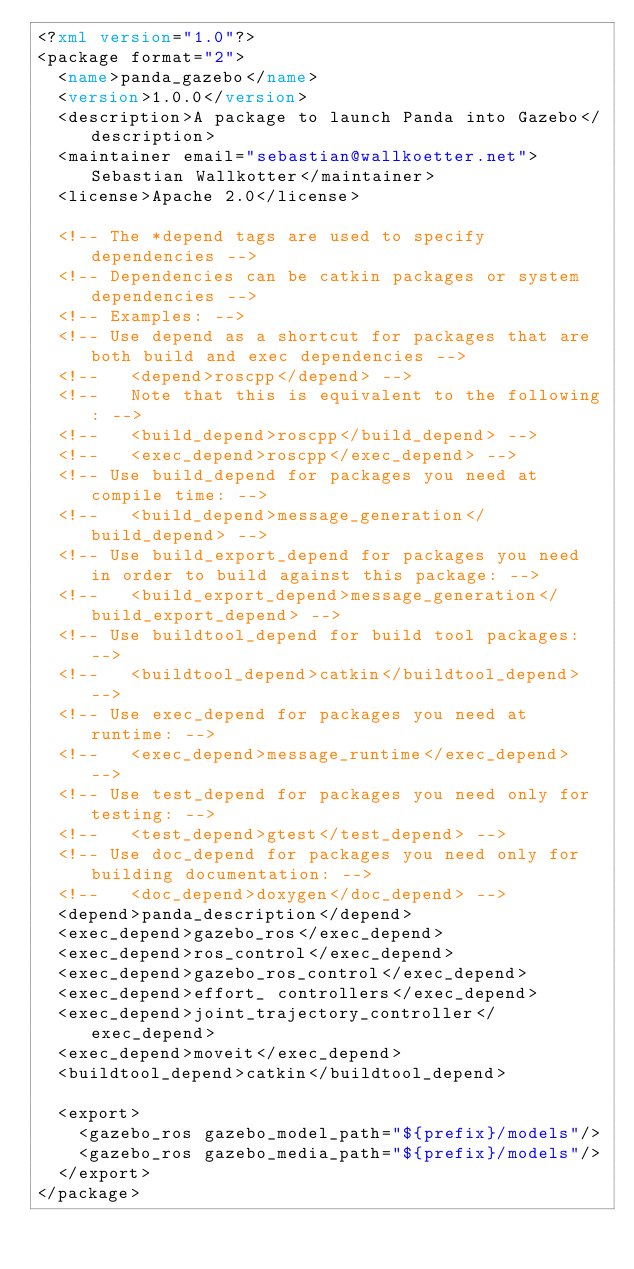Convert code to text. <code><loc_0><loc_0><loc_500><loc_500><_XML_><?xml version="1.0"?>
<package format="2">
  <name>panda_gazebo</name>
  <version>1.0.0</version>
  <description>A package to launch Panda into Gazebo</description>
  <maintainer email="sebastian@wallkoetter.net">Sebastian Wallkotter</maintainer>
  <license>Apache 2.0</license>

  <!-- The *depend tags are used to specify dependencies -->
  <!-- Dependencies can be catkin packages or system dependencies -->
  <!-- Examples: -->
  <!-- Use depend as a shortcut for packages that are both build and exec dependencies -->
  <!--   <depend>roscpp</depend> -->
  <!--   Note that this is equivalent to the following: -->
  <!--   <build_depend>roscpp</build_depend> -->
  <!--   <exec_depend>roscpp</exec_depend> -->
  <!-- Use build_depend for packages you need at compile time: -->
  <!--   <build_depend>message_generation</build_depend> -->
  <!-- Use build_export_depend for packages you need in order to build against this package: -->
  <!--   <build_export_depend>message_generation</build_export_depend> -->
  <!-- Use buildtool_depend for build tool packages: -->
  <!--   <buildtool_depend>catkin</buildtool_depend> -->
  <!-- Use exec_depend for packages you need at runtime: -->
  <!--   <exec_depend>message_runtime</exec_depend> -->
  <!-- Use test_depend for packages you need only for testing: -->
  <!--   <test_depend>gtest</test_depend> -->
  <!-- Use doc_depend for packages you need only for building documentation: -->
  <!--   <doc_depend>doxygen</doc_depend> -->
  <depend>panda_description</depend>
  <exec_depend>gazebo_ros</exec_depend>
  <exec_depend>ros_control</exec_depend>
  <exec_depend>gazebo_ros_control</exec_depend>
  <exec_depend>effort_ controllers</exec_depend>
  <exec_depend>joint_trajectory_controller</exec_depend>
  <exec_depend>moveit</exec_depend>
  <buildtool_depend>catkin</buildtool_depend>

  <export>
    <gazebo_ros gazebo_model_path="${prefix}/models"/>
    <gazebo_ros gazebo_media_path="${prefix}/models"/>
  </export>
</package>
</code> 